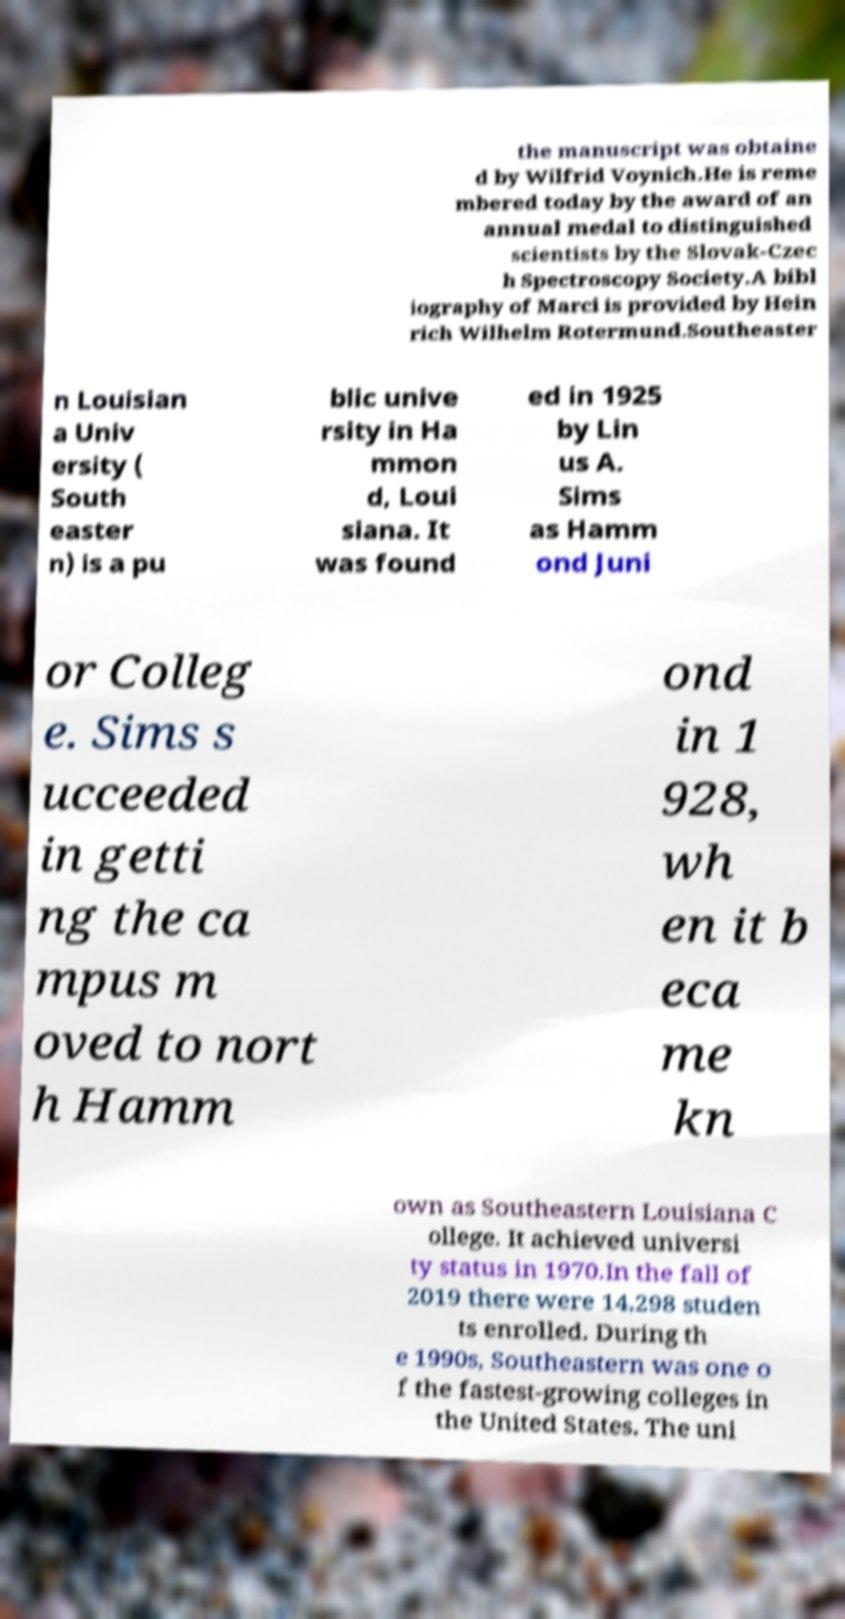Could you assist in decoding the text presented in this image and type it out clearly? the manuscript was obtaine d by Wilfrid Voynich.He is reme mbered today by the award of an annual medal to distinguished scientists by the Slovak-Czec h Spectroscopy Society.A bibl iography of Marci is provided by Hein rich Wilhelm Rotermund.Southeaster n Louisian a Univ ersity ( South easter n) is a pu blic unive rsity in Ha mmon d, Loui siana. It was found ed in 1925 by Lin us A. Sims as Hamm ond Juni or Colleg e. Sims s ucceeded in getti ng the ca mpus m oved to nort h Hamm ond in 1 928, wh en it b eca me kn own as Southeastern Louisiana C ollege. It achieved universi ty status in 1970.In the fall of 2019 there were 14,298 studen ts enrolled. During th e 1990s, Southeastern was one o f the fastest-growing colleges in the United States. The uni 